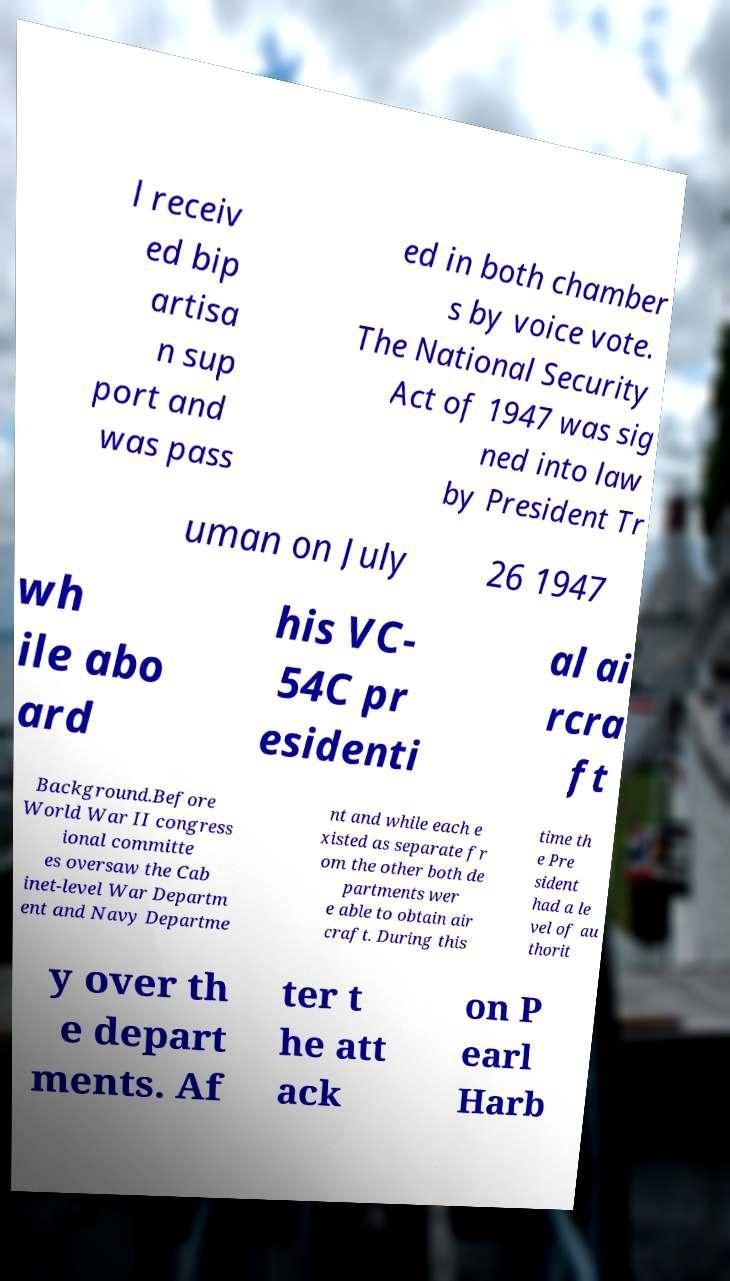There's text embedded in this image that I need extracted. Can you transcribe it verbatim? l receiv ed bip artisa n sup port and was pass ed in both chamber s by voice vote. The National Security Act of 1947 was sig ned into law by President Tr uman on July 26 1947 wh ile abo ard his VC- 54C pr esidenti al ai rcra ft Background.Before World War II congress ional committe es oversaw the Cab inet-level War Departm ent and Navy Departme nt and while each e xisted as separate fr om the other both de partments wer e able to obtain air craft. During this time th e Pre sident had a le vel of au thorit y over th e depart ments. Af ter t he att ack on P earl Harb 